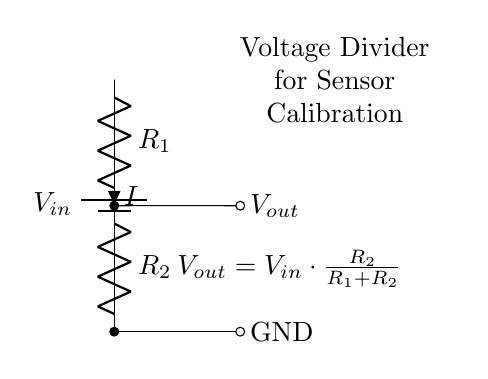What is the input voltage in this circuit? The input voltage is denoted as V in the circuit diagram, but no specific value is provided. It is simply represented as V in.
Answer: V in What are the resistor values in the circuit? The circuit diagram labels the resistors as R1 and R2, but it does not indicate specific numerical values for them. They are generic representations of resistors in a voltage divider setup.
Answer: R1 and R2 What is the expression for the output voltage? The output voltage formula is given directly in the diagram as V out = V in * (R2 / (R1 + R2)), which shows how V out depends on the values of the resistors and the input voltage.
Answer: V out = V in * (R2 / (R1 + R2)) If R1 is twice the value of R2, what is the output voltage ratio? If R1 is twice R2, let R2 be x, then R1 is 2x. The output voltage would be V out = V in * (x / (2x + x)) = V in * (1/3). The output voltage is one-third of the input voltage in this specific case.
Answer: One-third What happens to the output voltage if R2 is removed? If R2 is removed, the circuit is left with only R1 in series. This changes the configuration to a direct connection to ground, resulting in V out dropping to zero since there is no resistive path left for voltage division.
Answer: Zero What does the current I represent in this circuit? The current I is marked as the current flowing through the resistors R1 and R2 due to the applied input voltage V in. It is the same for both resistors in a series configuration.
Answer: Current through R1 and R2 